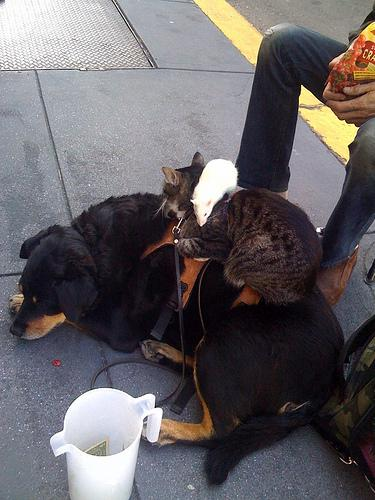Which mammal will disturb more species with it's movement? Please explain your reasoning. dog. There is a cat and a mouse on his back. 